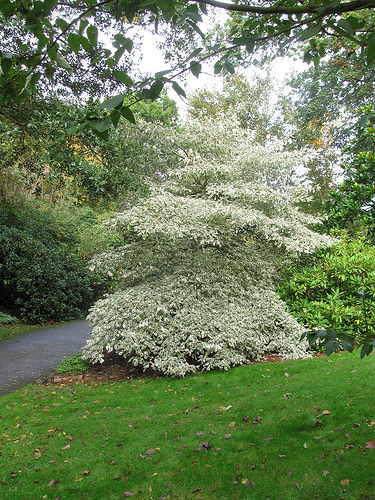<image>
Can you confirm if the grass is behind the road? Yes. From this viewpoint, the grass is positioned behind the road, with the road partially or fully occluding the grass. 